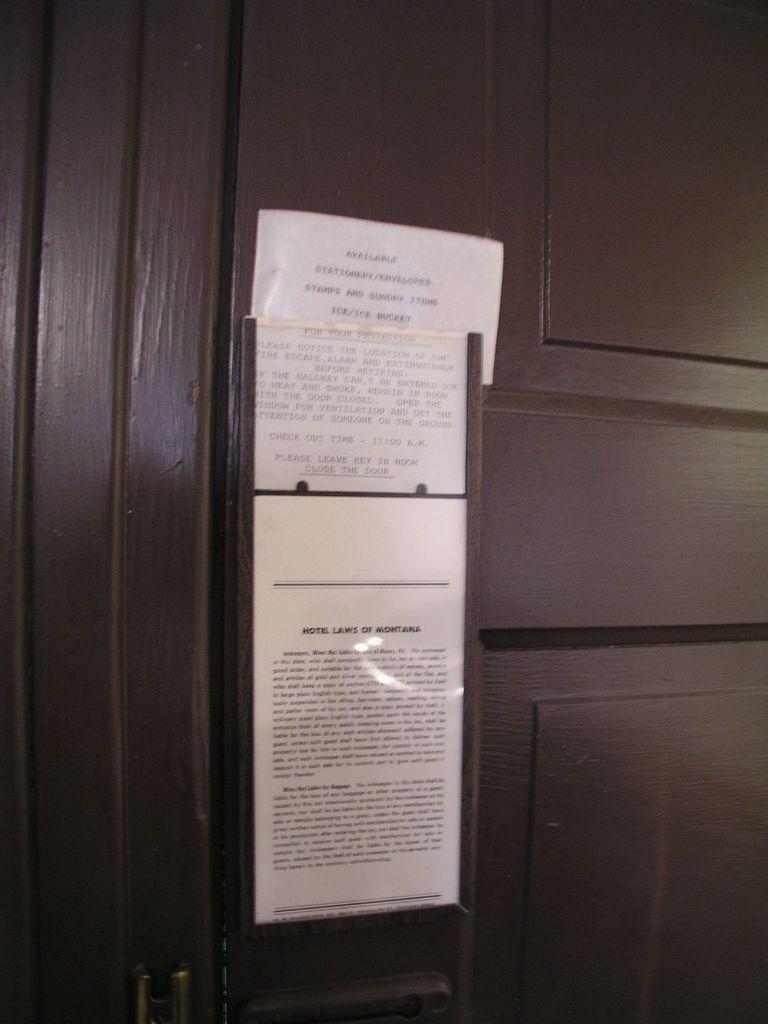What does the sign say?
Provide a short and direct response. Hotel laws of montana. 